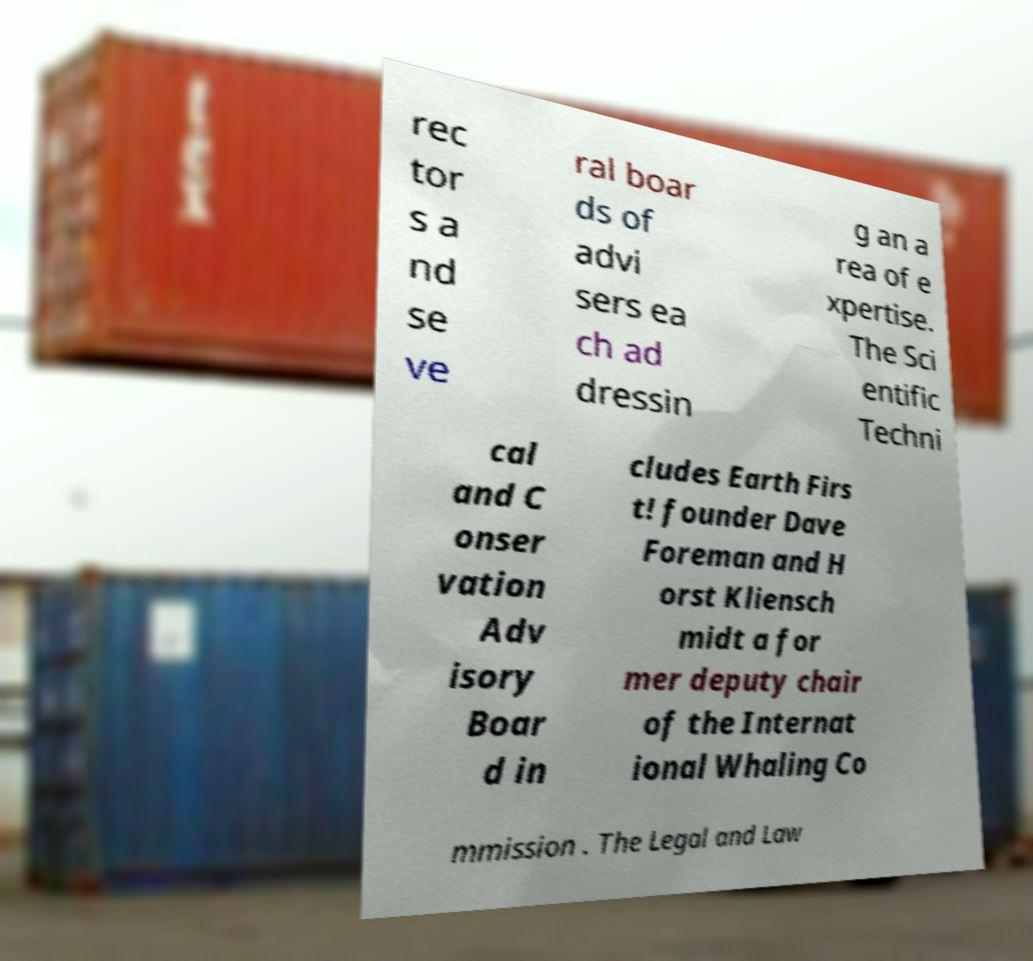Could you assist in decoding the text presented in this image and type it out clearly? rec tor s a nd se ve ral boar ds of advi sers ea ch ad dressin g an a rea of e xpertise. The Sci entific Techni cal and C onser vation Adv isory Boar d in cludes Earth Firs t! founder Dave Foreman and H orst Kliensch midt a for mer deputy chair of the Internat ional Whaling Co mmission . The Legal and Law 